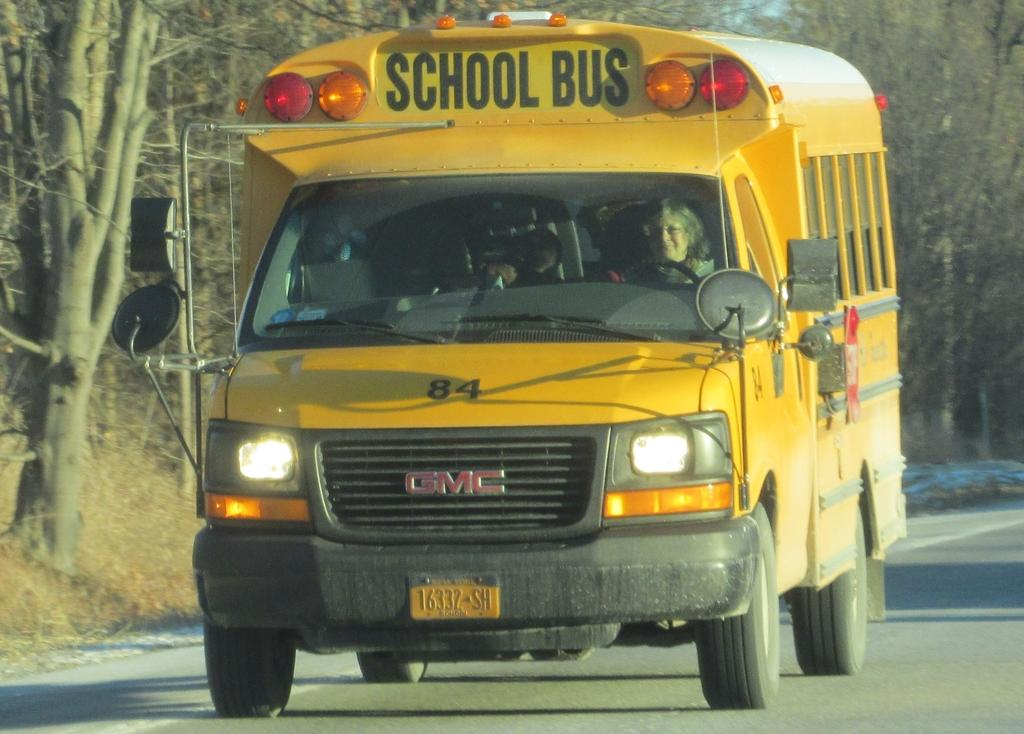<image>
Render a clear and concise summary of the photo. 16322SH reads the license plate of this school bus. 